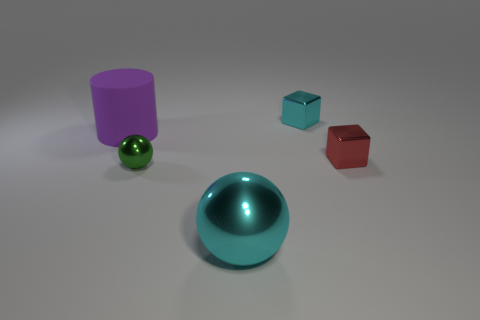Are there fewer big cylinders to the right of the big cyan ball than big matte objects?
Your answer should be very brief. Yes. Does the cyan thing that is behind the cyan metal sphere have the same size as the large cyan sphere?
Offer a terse response. No. What number of tiny green things are the same shape as the large metal object?
Keep it short and to the point. 1. What size is the red object that is the same material as the tiny sphere?
Make the answer very short. Small. Are there an equal number of tiny green metal spheres that are in front of the big cyan object and green balls?
Your response must be concise. No. Is the color of the large matte object the same as the tiny metallic sphere?
Your response must be concise. No. Does the big thing behind the big metallic ball have the same shape as the metallic thing in front of the green thing?
Make the answer very short. No. There is another large thing that is the same shape as the green object; what is it made of?
Your answer should be compact. Metal. What is the color of the thing that is on the left side of the large metallic ball and in front of the large cylinder?
Your answer should be compact. Green. There is a small block on the right side of the tiny thing that is behind the red shiny thing; are there any cyan metallic cubes in front of it?
Provide a short and direct response. No. 